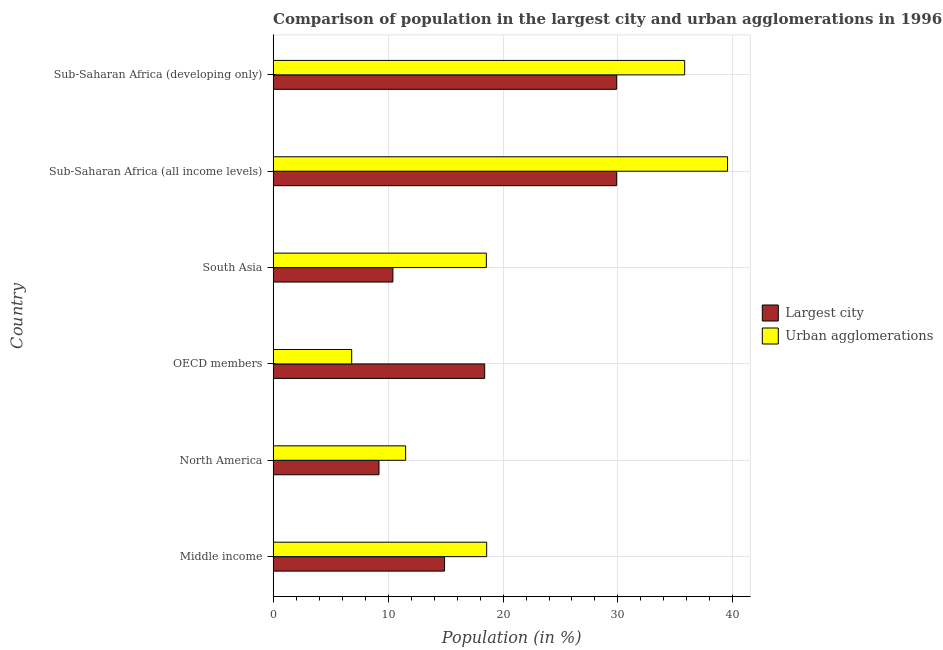How many different coloured bars are there?
Ensure brevity in your answer.  2. How many groups of bars are there?
Your response must be concise. 6. How many bars are there on the 5th tick from the top?
Make the answer very short. 2. How many bars are there on the 6th tick from the bottom?
Offer a terse response. 2. What is the label of the 5th group of bars from the top?
Your answer should be compact. North America. In how many cases, is the number of bars for a given country not equal to the number of legend labels?
Provide a short and direct response. 0. What is the population in urban agglomerations in Sub-Saharan Africa (all income levels)?
Your response must be concise. 39.53. Across all countries, what is the maximum population in urban agglomerations?
Ensure brevity in your answer.  39.53. Across all countries, what is the minimum population in the largest city?
Provide a short and direct response. 9.21. In which country was the population in the largest city maximum?
Your response must be concise. Sub-Saharan Africa (all income levels). In which country was the population in urban agglomerations minimum?
Ensure brevity in your answer.  OECD members. What is the total population in urban agglomerations in the graph?
Make the answer very short. 130.82. What is the difference between the population in urban agglomerations in Middle income and that in Sub-Saharan Africa (all income levels)?
Offer a very short reply. -20.96. What is the difference between the population in the largest city in Middle income and the population in urban agglomerations in North America?
Give a very brief answer. 3.39. What is the average population in urban agglomerations per country?
Your response must be concise. 21.8. What is the difference between the population in urban agglomerations and population in the largest city in South Asia?
Provide a succinct answer. 8.13. What is the ratio of the population in urban agglomerations in North America to that in South Asia?
Offer a terse response. 0.62. Is the population in the largest city in North America less than that in Sub-Saharan Africa (developing only)?
Your answer should be very brief. Yes. Is the difference between the population in urban agglomerations in South Asia and Sub-Saharan Africa (all income levels) greater than the difference between the population in the largest city in South Asia and Sub-Saharan Africa (all income levels)?
Provide a short and direct response. No. What is the difference between the highest and the second highest population in urban agglomerations?
Make the answer very short. 3.73. What is the difference between the highest and the lowest population in urban agglomerations?
Provide a short and direct response. 32.7. In how many countries, is the population in the largest city greater than the average population in the largest city taken over all countries?
Offer a terse response. 2. Is the sum of the population in the largest city in North America and OECD members greater than the maximum population in urban agglomerations across all countries?
Ensure brevity in your answer.  No. What does the 1st bar from the top in South Asia represents?
Offer a very short reply. Urban agglomerations. What does the 2nd bar from the bottom in OECD members represents?
Your response must be concise. Urban agglomerations. What is the difference between two consecutive major ticks on the X-axis?
Provide a succinct answer. 10. Are the values on the major ticks of X-axis written in scientific E-notation?
Offer a very short reply. No. Does the graph contain any zero values?
Keep it short and to the point. No. Where does the legend appear in the graph?
Keep it short and to the point. Center right. What is the title of the graph?
Ensure brevity in your answer.  Comparison of population in the largest city and urban agglomerations in 1996. What is the Population (in %) in Largest city in Middle income?
Ensure brevity in your answer.  14.91. What is the Population (in %) of Urban agglomerations in Middle income?
Offer a very short reply. 18.58. What is the Population (in %) of Largest city in North America?
Make the answer very short. 9.21. What is the Population (in %) in Urban agglomerations in North America?
Provide a short and direct response. 11.53. What is the Population (in %) of Largest city in OECD members?
Ensure brevity in your answer.  18.41. What is the Population (in %) of Urban agglomerations in OECD members?
Your answer should be compact. 6.83. What is the Population (in %) of Largest city in South Asia?
Your response must be concise. 10.42. What is the Population (in %) in Urban agglomerations in South Asia?
Offer a terse response. 18.55. What is the Population (in %) of Largest city in Sub-Saharan Africa (all income levels)?
Make the answer very short. 29.89. What is the Population (in %) in Urban agglomerations in Sub-Saharan Africa (all income levels)?
Your response must be concise. 39.53. What is the Population (in %) in Largest city in Sub-Saharan Africa (developing only)?
Your answer should be very brief. 29.89. What is the Population (in %) of Urban agglomerations in Sub-Saharan Africa (developing only)?
Keep it short and to the point. 35.8. Across all countries, what is the maximum Population (in %) in Largest city?
Offer a very short reply. 29.89. Across all countries, what is the maximum Population (in %) of Urban agglomerations?
Offer a very short reply. 39.53. Across all countries, what is the minimum Population (in %) in Largest city?
Offer a very short reply. 9.21. Across all countries, what is the minimum Population (in %) in Urban agglomerations?
Make the answer very short. 6.83. What is the total Population (in %) of Largest city in the graph?
Ensure brevity in your answer.  112.73. What is the total Population (in %) of Urban agglomerations in the graph?
Provide a succinct answer. 130.82. What is the difference between the Population (in %) in Largest city in Middle income and that in North America?
Provide a short and direct response. 5.7. What is the difference between the Population (in %) in Urban agglomerations in Middle income and that in North America?
Your answer should be very brief. 7.05. What is the difference between the Population (in %) in Largest city in Middle income and that in OECD members?
Offer a terse response. -3.49. What is the difference between the Population (in %) of Urban agglomerations in Middle income and that in OECD members?
Offer a terse response. 11.74. What is the difference between the Population (in %) of Largest city in Middle income and that in South Asia?
Make the answer very short. 4.49. What is the difference between the Population (in %) of Urban agglomerations in Middle income and that in South Asia?
Provide a short and direct response. 0.03. What is the difference between the Population (in %) in Largest city in Middle income and that in Sub-Saharan Africa (all income levels)?
Make the answer very short. -14.97. What is the difference between the Population (in %) in Urban agglomerations in Middle income and that in Sub-Saharan Africa (all income levels)?
Ensure brevity in your answer.  -20.96. What is the difference between the Population (in %) in Largest city in Middle income and that in Sub-Saharan Africa (developing only)?
Keep it short and to the point. -14.97. What is the difference between the Population (in %) in Urban agglomerations in Middle income and that in Sub-Saharan Africa (developing only)?
Offer a terse response. -17.23. What is the difference between the Population (in %) in Largest city in North America and that in OECD members?
Your answer should be very brief. -9.2. What is the difference between the Population (in %) in Urban agglomerations in North America and that in OECD members?
Give a very brief answer. 4.69. What is the difference between the Population (in %) in Largest city in North America and that in South Asia?
Offer a very short reply. -1.21. What is the difference between the Population (in %) in Urban agglomerations in North America and that in South Asia?
Offer a very short reply. -7.02. What is the difference between the Population (in %) in Largest city in North America and that in Sub-Saharan Africa (all income levels)?
Your response must be concise. -20.68. What is the difference between the Population (in %) of Urban agglomerations in North America and that in Sub-Saharan Africa (all income levels)?
Your response must be concise. -28.01. What is the difference between the Population (in %) of Largest city in North America and that in Sub-Saharan Africa (developing only)?
Make the answer very short. -20.68. What is the difference between the Population (in %) in Urban agglomerations in North America and that in Sub-Saharan Africa (developing only)?
Provide a short and direct response. -24.28. What is the difference between the Population (in %) of Largest city in OECD members and that in South Asia?
Your answer should be compact. 7.99. What is the difference between the Population (in %) of Urban agglomerations in OECD members and that in South Asia?
Provide a succinct answer. -11.71. What is the difference between the Population (in %) in Largest city in OECD members and that in Sub-Saharan Africa (all income levels)?
Your answer should be compact. -11.48. What is the difference between the Population (in %) of Urban agglomerations in OECD members and that in Sub-Saharan Africa (all income levels)?
Make the answer very short. -32.7. What is the difference between the Population (in %) in Largest city in OECD members and that in Sub-Saharan Africa (developing only)?
Offer a terse response. -11.48. What is the difference between the Population (in %) of Urban agglomerations in OECD members and that in Sub-Saharan Africa (developing only)?
Provide a short and direct response. -28.97. What is the difference between the Population (in %) in Largest city in South Asia and that in Sub-Saharan Africa (all income levels)?
Your answer should be compact. -19.47. What is the difference between the Population (in %) of Urban agglomerations in South Asia and that in Sub-Saharan Africa (all income levels)?
Your answer should be very brief. -20.98. What is the difference between the Population (in %) of Largest city in South Asia and that in Sub-Saharan Africa (developing only)?
Provide a short and direct response. -19.47. What is the difference between the Population (in %) in Urban agglomerations in South Asia and that in Sub-Saharan Africa (developing only)?
Give a very brief answer. -17.25. What is the difference between the Population (in %) in Largest city in Sub-Saharan Africa (all income levels) and that in Sub-Saharan Africa (developing only)?
Provide a short and direct response. 0. What is the difference between the Population (in %) in Urban agglomerations in Sub-Saharan Africa (all income levels) and that in Sub-Saharan Africa (developing only)?
Offer a terse response. 3.73. What is the difference between the Population (in %) in Largest city in Middle income and the Population (in %) in Urban agglomerations in North America?
Your answer should be very brief. 3.39. What is the difference between the Population (in %) in Largest city in Middle income and the Population (in %) in Urban agglomerations in OECD members?
Your answer should be very brief. 8.08. What is the difference between the Population (in %) of Largest city in Middle income and the Population (in %) of Urban agglomerations in South Asia?
Your answer should be compact. -3.64. What is the difference between the Population (in %) in Largest city in Middle income and the Population (in %) in Urban agglomerations in Sub-Saharan Africa (all income levels)?
Your response must be concise. -24.62. What is the difference between the Population (in %) of Largest city in Middle income and the Population (in %) of Urban agglomerations in Sub-Saharan Africa (developing only)?
Provide a succinct answer. -20.89. What is the difference between the Population (in %) of Largest city in North America and the Population (in %) of Urban agglomerations in OECD members?
Ensure brevity in your answer.  2.38. What is the difference between the Population (in %) in Largest city in North America and the Population (in %) in Urban agglomerations in South Asia?
Your answer should be compact. -9.34. What is the difference between the Population (in %) in Largest city in North America and the Population (in %) in Urban agglomerations in Sub-Saharan Africa (all income levels)?
Your answer should be compact. -30.32. What is the difference between the Population (in %) in Largest city in North America and the Population (in %) in Urban agglomerations in Sub-Saharan Africa (developing only)?
Ensure brevity in your answer.  -26.59. What is the difference between the Population (in %) in Largest city in OECD members and the Population (in %) in Urban agglomerations in South Asia?
Your answer should be compact. -0.14. What is the difference between the Population (in %) in Largest city in OECD members and the Population (in %) in Urban agglomerations in Sub-Saharan Africa (all income levels)?
Make the answer very short. -21.13. What is the difference between the Population (in %) in Largest city in OECD members and the Population (in %) in Urban agglomerations in Sub-Saharan Africa (developing only)?
Provide a short and direct response. -17.4. What is the difference between the Population (in %) in Largest city in South Asia and the Population (in %) in Urban agglomerations in Sub-Saharan Africa (all income levels)?
Keep it short and to the point. -29.11. What is the difference between the Population (in %) in Largest city in South Asia and the Population (in %) in Urban agglomerations in Sub-Saharan Africa (developing only)?
Make the answer very short. -25.38. What is the difference between the Population (in %) of Largest city in Sub-Saharan Africa (all income levels) and the Population (in %) of Urban agglomerations in Sub-Saharan Africa (developing only)?
Provide a short and direct response. -5.92. What is the average Population (in %) in Largest city per country?
Ensure brevity in your answer.  18.79. What is the average Population (in %) of Urban agglomerations per country?
Give a very brief answer. 21.8. What is the difference between the Population (in %) in Largest city and Population (in %) in Urban agglomerations in Middle income?
Your answer should be very brief. -3.66. What is the difference between the Population (in %) in Largest city and Population (in %) in Urban agglomerations in North America?
Your answer should be compact. -2.32. What is the difference between the Population (in %) of Largest city and Population (in %) of Urban agglomerations in OECD members?
Provide a succinct answer. 11.57. What is the difference between the Population (in %) in Largest city and Population (in %) in Urban agglomerations in South Asia?
Provide a short and direct response. -8.13. What is the difference between the Population (in %) of Largest city and Population (in %) of Urban agglomerations in Sub-Saharan Africa (all income levels)?
Give a very brief answer. -9.65. What is the difference between the Population (in %) of Largest city and Population (in %) of Urban agglomerations in Sub-Saharan Africa (developing only)?
Your answer should be compact. -5.92. What is the ratio of the Population (in %) in Largest city in Middle income to that in North America?
Your response must be concise. 1.62. What is the ratio of the Population (in %) in Urban agglomerations in Middle income to that in North America?
Make the answer very short. 1.61. What is the ratio of the Population (in %) in Largest city in Middle income to that in OECD members?
Your answer should be very brief. 0.81. What is the ratio of the Population (in %) of Urban agglomerations in Middle income to that in OECD members?
Offer a terse response. 2.72. What is the ratio of the Population (in %) of Largest city in Middle income to that in South Asia?
Make the answer very short. 1.43. What is the ratio of the Population (in %) in Urban agglomerations in Middle income to that in South Asia?
Make the answer very short. 1. What is the ratio of the Population (in %) of Largest city in Middle income to that in Sub-Saharan Africa (all income levels)?
Your answer should be compact. 0.5. What is the ratio of the Population (in %) in Urban agglomerations in Middle income to that in Sub-Saharan Africa (all income levels)?
Your answer should be very brief. 0.47. What is the ratio of the Population (in %) in Largest city in Middle income to that in Sub-Saharan Africa (developing only)?
Your response must be concise. 0.5. What is the ratio of the Population (in %) in Urban agglomerations in Middle income to that in Sub-Saharan Africa (developing only)?
Give a very brief answer. 0.52. What is the ratio of the Population (in %) of Largest city in North America to that in OECD members?
Offer a terse response. 0.5. What is the ratio of the Population (in %) in Urban agglomerations in North America to that in OECD members?
Your answer should be very brief. 1.69. What is the ratio of the Population (in %) in Largest city in North America to that in South Asia?
Keep it short and to the point. 0.88. What is the ratio of the Population (in %) in Urban agglomerations in North America to that in South Asia?
Make the answer very short. 0.62. What is the ratio of the Population (in %) of Largest city in North America to that in Sub-Saharan Africa (all income levels)?
Keep it short and to the point. 0.31. What is the ratio of the Population (in %) of Urban agglomerations in North America to that in Sub-Saharan Africa (all income levels)?
Provide a succinct answer. 0.29. What is the ratio of the Population (in %) in Largest city in North America to that in Sub-Saharan Africa (developing only)?
Offer a terse response. 0.31. What is the ratio of the Population (in %) in Urban agglomerations in North America to that in Sub-Saharan Africa (developing only)?
Make the answer very short. 0.32. What is the ratio of the Population (in %) in Largest city in OECD members to that in South Asia?
Ensure brevity in your answer.  1.77. What is the ratio of the Population (in %) in Urban agglomerations in OECD members to that in South Asia?
Offer a very short reply. 0.37. What is the ratio of the Population (in %) in Largest city in OECD members to that in Sub-Saharan Africa (all income levels)?
Make the answer very short. 0.62. What is the ratio of the Population (in %) in Urban agglomerations in OECD members to that in Sub-Saharan Africa (all income levels)?
Provide a short and direct response. 0.17. What is the ratio of the Population (in %) in Largest city in OECD members to that in Sub-Saharan Africa (developing only)?
Offer a very short reply. 0.62. What is the ratio of the Population (in %) of Urban agglomerations in OECD members to that in Sub-Saharan Africa (developing only)?
Provide a short and direct response. 0.19. What is the ratio of the Population (in %) in Largest city in South Asia to that in Sub-Saharan Africa (all income levels)?
Keep it short and to the point. 0.35. What is the ratio of the Population (in %) of Urban agglomerations in South Asia to that in Sub-Saharan Africa (all income levels)?
Make the answer very short. 0.47. What is the ratio of the Population (in %) in Largest city in South Asia to that in Sub-Saharan Africa (developing only)?
Your answer should be very brief. 0.35. What is the ratio of the Population (in %) in Urban agglomerations in South Asia to that in Sub-Saharan Africa (developing only)?
Your response must be concise. 0.52. What is the ratio of the Population (in %) in Largest city in Sub-Saharan Africa (all income levels) to that in Sub-Saharan Africa (developing only)?
Your answer should be very brief. 1. What is the ratio of the Population (in %) in Urban agglomerations in Sub-Saharan Africa (all income levels) to that in Sub-Saharan Africa (developing only)?
Provide a succinct answer. 1.1. What is the difference between the highest and the second highest Population (in %) in Urban agglomerations?
Make the answer very short. 3.73. What is the difference between the highest and the lowest Population (in %) of Largest city?
Make the answer very short. 20.68. What is the difference between the highest and the lowest Population (in %) of Urban agglomerations?
Make the answer very short. 32.7. 